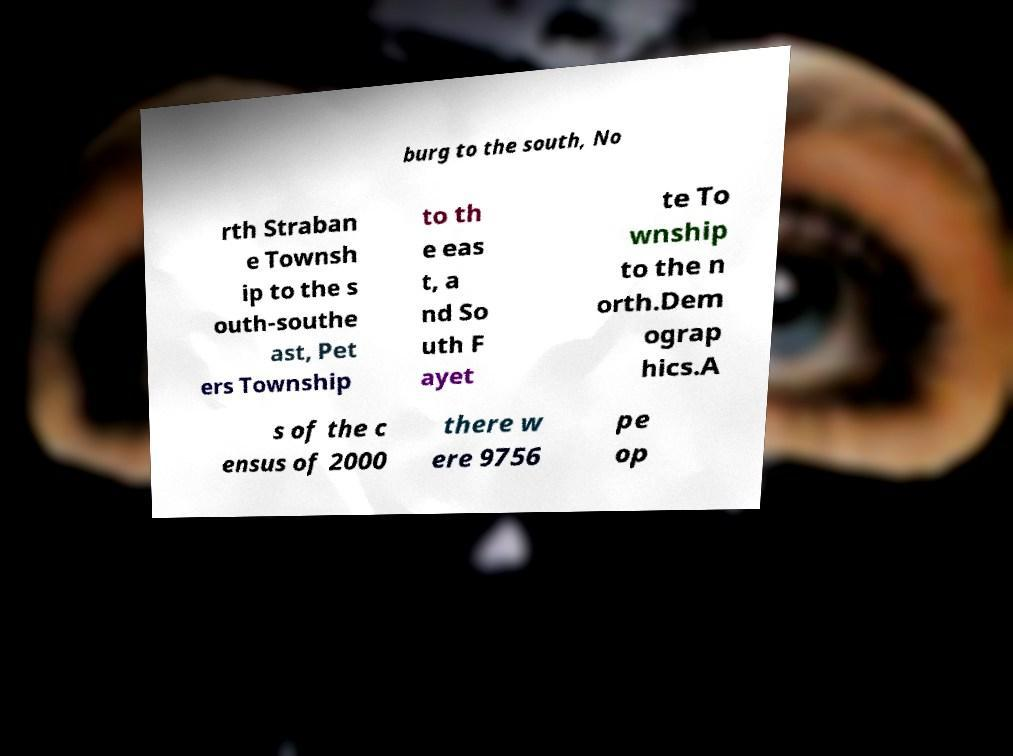Please identify and transcribe the text found in this image. burg to the south, No rth Straban e Townsh ip to the s outh-southe ast, Pet ers Township to th e eas t, a nd So uth F ayet te To wnship to the n orth.Dem ograp hics.A s of the c ensus of 2000 there w ere 9756 pe op 